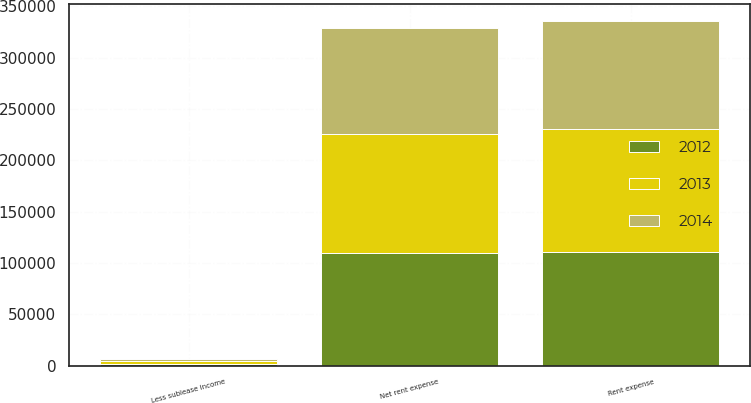<chart> <loc_0><loc_0><loc_500><loc_500><stacked_bar_chart><ecel><fcel>Rent expense<fcel>Less sublease income<fcel>Net rent expense<nl><fcel>2012<fcel>111149<fcel>1412<fcel>109737<nl><fcel>2013<fcel>118976<fcel>3057<fcel>115919<nl><fcel>2014<fcel>105809<fcel>2330<fcel>103479<nl></chart> 